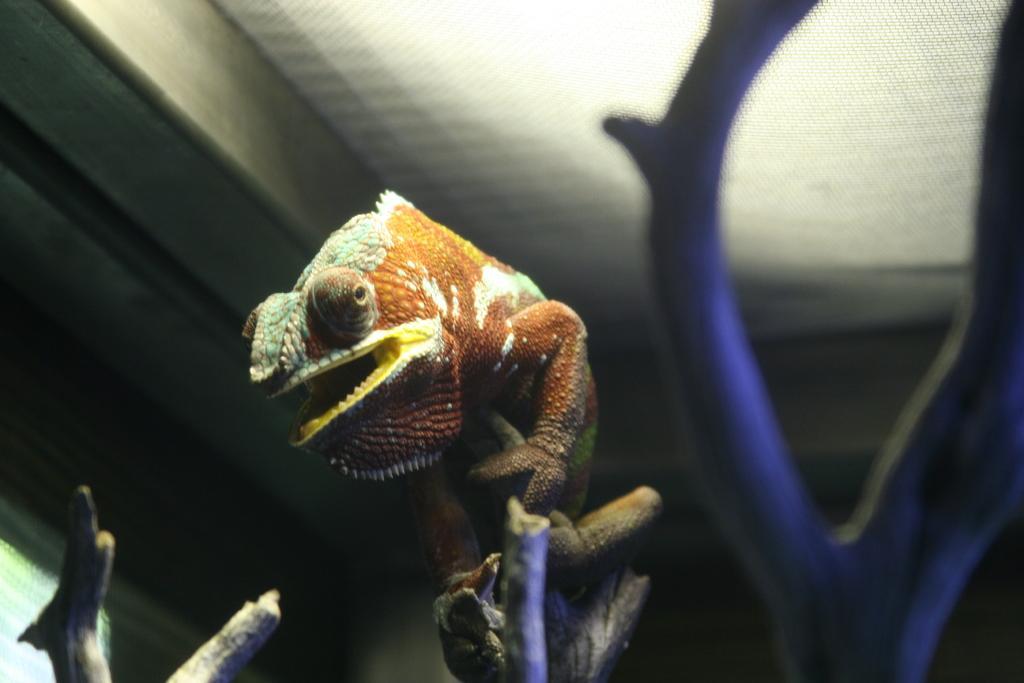How would you summarize this image in a sentence or two? In this image there is a lizard on the stem of a plant. At the top of the image there is a ceiling. 